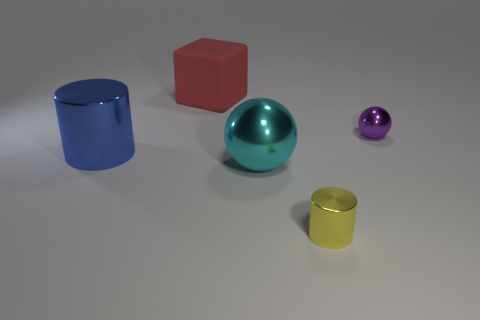Is there another blue thing of the same shape as the blue object?
Your answer should be compact. No. There is a rubber thing that is the same size as the blue shiny cylinder; what color is it?
Offer a terse response. Red. What is the material of the big red cube that is left of the big cyan metal ball?
Keep it short and to the point. Rubber. There is a small object that is in front of the big cyan shiny thing; does it have the same shape as the cyan metallic thing in front of the big matte object?
Make the answer very short. No. Are there an equal number of cubes behind the big red matte cube and small spheres?
Your response must be concise. No. What number of small purple balls have the same material as the blue object?
Give a very brief answer. 1. There is a small sphere that is the same material as the big blue cylinder; what color is it?
Make the answer very short. Purple. Is the size of the red matte cube the same as the cylinder that is right of the red matte object?
Make the answer very short. No. What is the shape of the blue metal thing?
Offer a terse response. Cylinder. What number of matte things have the same color as the big cube?
Ensure brevity in your answer.  0. 